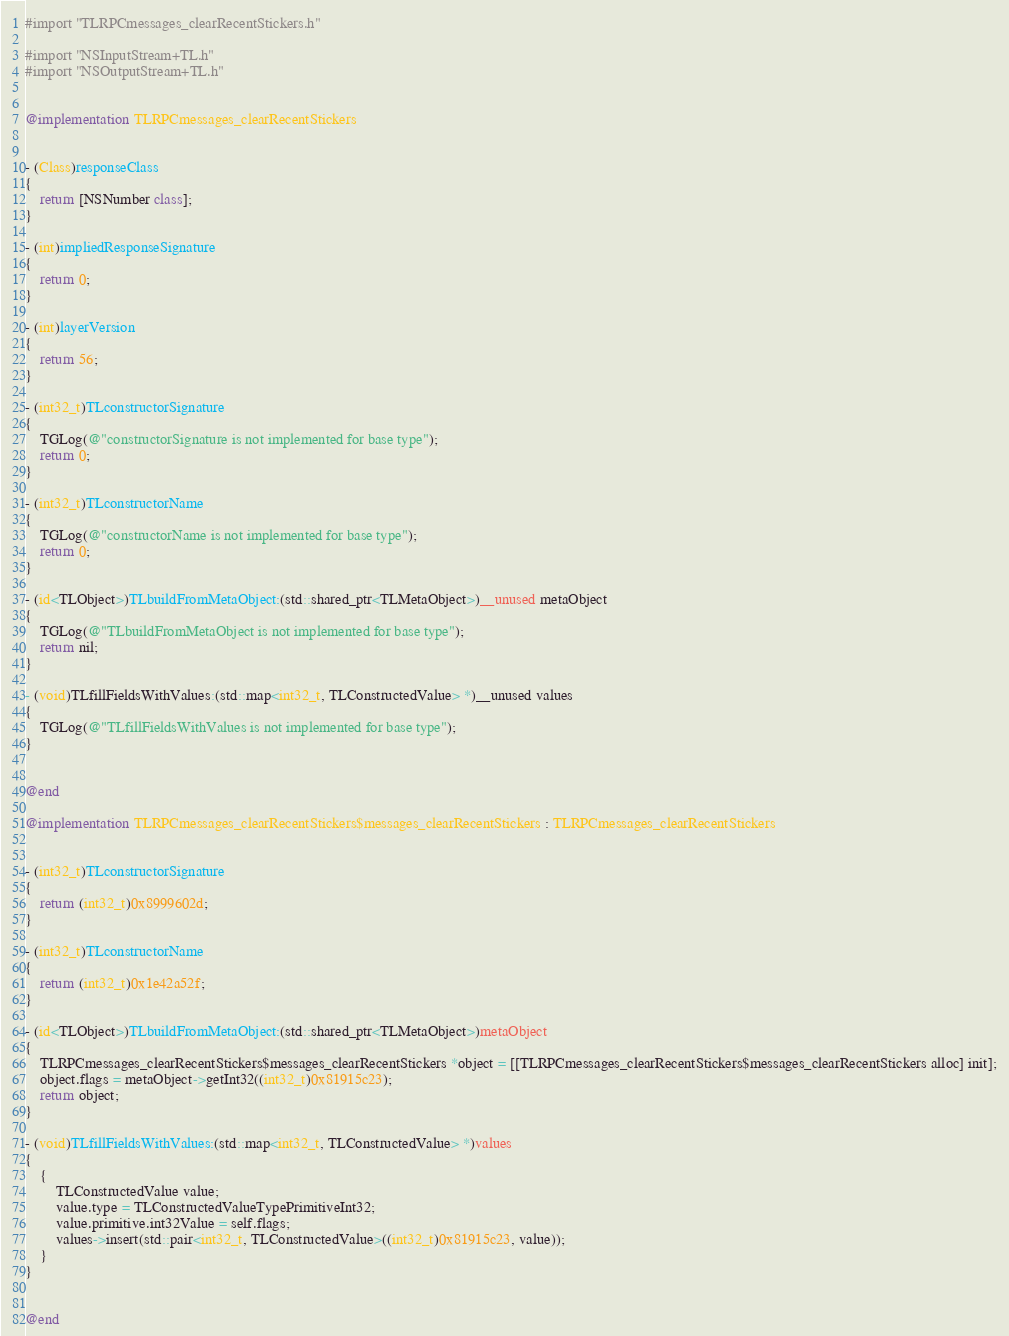Convert code to text. <code><loc_0><loc_0><loc_500><loc_500><_ObjectiveC_>#import "TLRPCmessages_clearRecentStickers.h"

#import "NSInputStream+TL.h"
#import "NSOutputStream+TL.h"


@implementation TLRPCmessages_clearRecentStickers


- (Class)responseClass
{
    return [NSNumber class];
}

- (int)impliedResponseSignature
{
    return 0;
}

- (int)layerVersion
{
    return 56;
}

- (int32_t)TLconstructorSignature
{
    TGLog(@"constructorSignature is not implemented for base type");
    return 0;
}

- (int32_t)TLconstructorName
{
    TGLog(@"constructorName is not implemented for base type");
    return 0;
}

- (id<TLObject>)TLbuildFromMetaObject:(std::shared_ptr<TLMetaObject>)__unused metaObject
{
    TGLog(@"TLbuildFromMetaObject is not implemented for base type");
    return nil;
}

- (void)TLfillFieldsWithValues:(std::map<int32_t, TLConstructedValue> *)__unused values
{
    TGLog(@"TLfillFieldsWithValues is not implemented for base type");
}


@end

@implementation TLRPCmessages_clearRecentStickers$messages_clearRecentStickers : TLRPCmessages_clearRecentStickers


- (int32_t)TLconstructorSignature
{
    return (int32_t)0x8999602d;
}

- (int32_t)TLconstructorName
{
    return (int32_t)0x1e42a52f;
}

- (id<TLObject>)TLbuildFromMetaObject:(std::shared_ptr<TLMetaObject>)metaObject
{
    TLRPCmessages_clearRecentStickers$messages_clearRecentStickers *object = [[TLRPCmessages_clearRecentStickers$messages_clearRecentStickers alloc] init];
    object.flags = metaObject->getInt32((int32_t)0x81915c23);
    return object;
}

- (void)TLfillFieldsWithValues:(std::map<int32_t, TLConstructedValue> *)values
{
    {
        TLConstructedValue value;
        value.type = TLConstructedValueTypePrimitiveInt32;
        value.primitive.int32Value = self.flags;
        values->insert(std::pair<int32_t, TLConstructedValue>((int32_t)0x81915c23, value));
    }
}


@end

</code> 